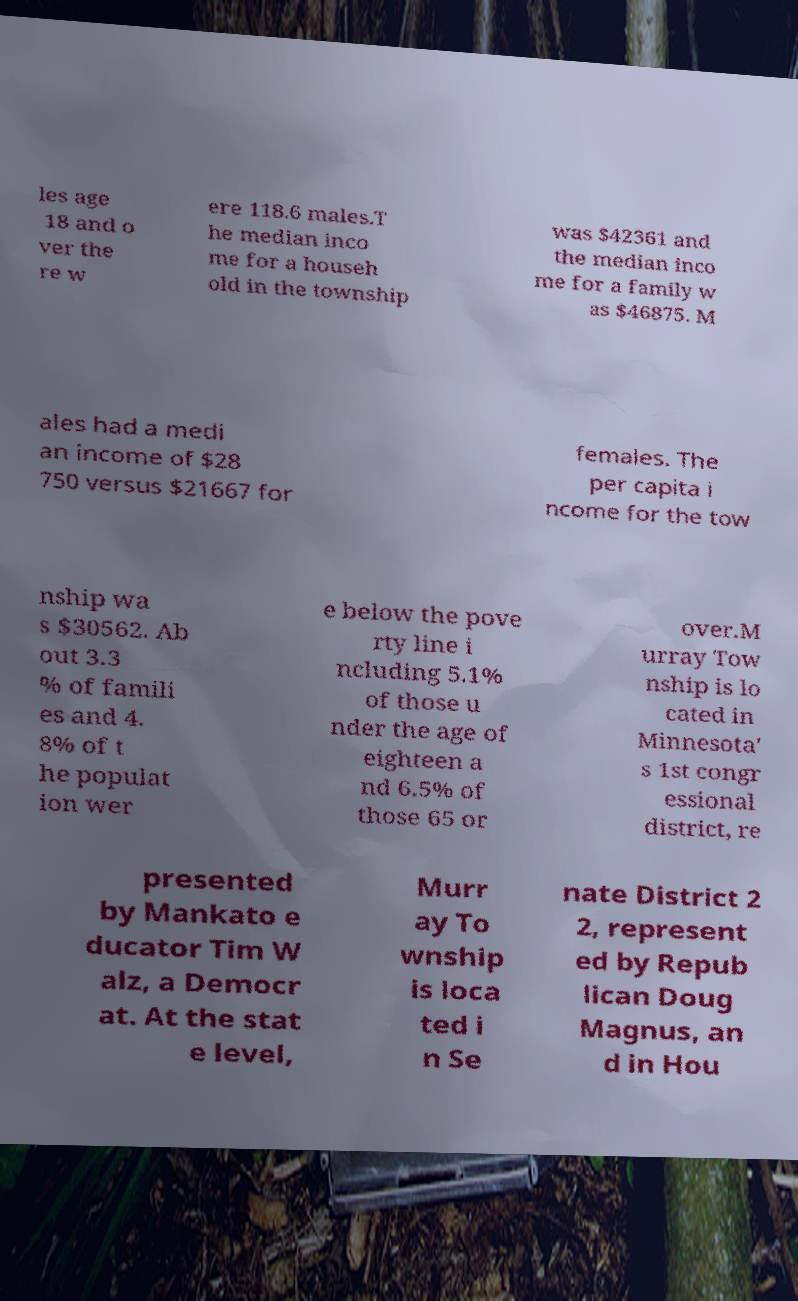Can you accurately transcribe the text from the provided image for me? les age 18 and o ver the re w ere 118.6 males.T he median inco me for a househ old in the township was $42361 and the median inco me for a family w as $46875. M ales had a medi an income of $28 750 versus $21667 for females. The per capita i ncome for the tow nship wa s $30562. Ab out 3.3 % of famili es and 4. 8% of t he populat ion wer e below the pove rty line i ncluding 5.1% of those u nder the age of eighteen a nd 6.5% of those 65 or over.M urray Tow nship is lo cated in Minnesota' s 1st congr essional district, re presented by Mankato e ducator Tim W alz, a Democr at. At the stat e level, Murr ay To wnship is loca ted i n Se nate District 2 2, represent ed by Repub lican Doug Magnus, an d in Hou 